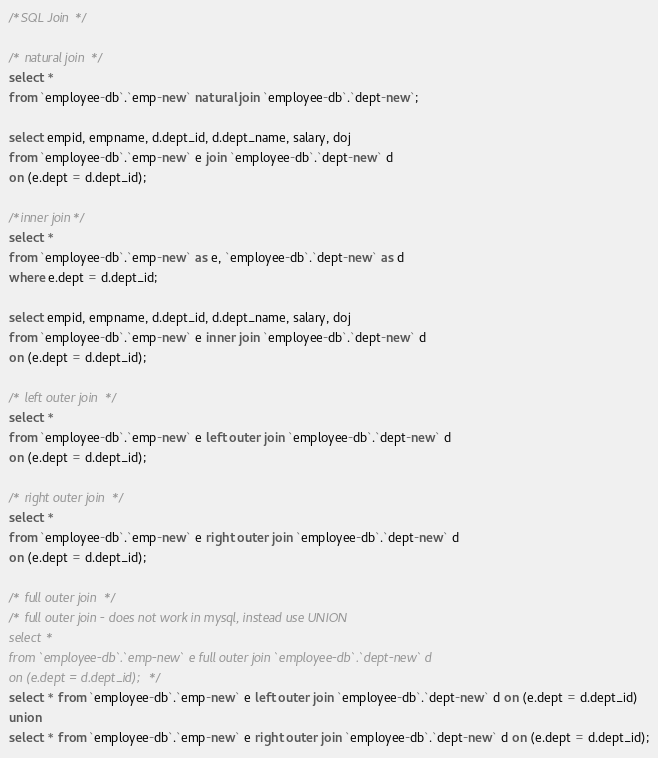<code> <loc_0><loc_0><loc_500><loc_500><_SQL_>/*SQL Join */

/* natural join */
select *
from `employee-db`.`emp-new` natural join `employee-db`.`dept-new`;

select empid, empname, d.dept_id, d.dept_name, salary, doj
from `employee-db`.`emp-new` e join `employee-db`.`dept-new` d
on (e.dept = d.dept_id);

/*inner join*/
select *
from `employee-db`.`emp-new` as e, `employee-db`.`dept-new` as d
where e.dept = d.dept_id;

select empid, empname, d.dept_id, d.dept_name, salary, doj
from `employee-db`.`emp-new` e inner join `employee-db`.`dept-new` d
on (e.dept = d.dept_id);

/* left outer join */
select *
from `employee-db`.`emp-new` e left outer join `employee-db`.`dept-new` d
on (e.dept = d.dept_id);

/* right outer join */
select *
from `employee-db`.`emp-new` e right outer join `employee-db`.`dept-new` d
on (e.dept = d.dept_id);

/* full outer join */
/* full outer join - does not work in mysql, instead use UNION
select *
from `employee-db`.`emp-new` e full outer join `employee-db`.`dept-new` d
on (e.dept = d.dept_id); */
select * from `employee-db`.`emp-new` e left outer join `employee-db`.`dept-new` d on (e.dept = d.dept_id)
union
select * from `employee-db`.`emp-new` e right outer join `employee-db`.`dept-new` d on (e.dept = d.dept_id);</code> 